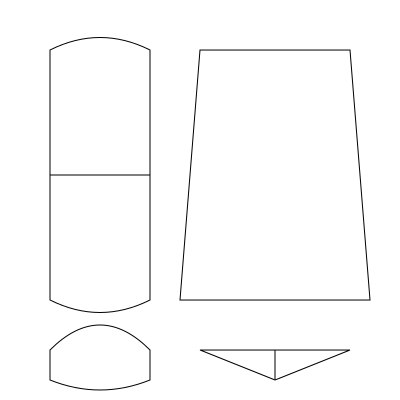As a culture writer, identify the musical instrument that originates from Aboriginal Australian culture and is known for its distinctive drone sound. To answer this question, let's analyze each instrument depicted in the image:

1. Top-left: This is a sitar, a stringed instrument from India. It has a long neck and a large, pear-shaped resonating chamber.

2. Top-right: This is a didgeridoo, a wind instrument developed by Indigenous Australians. It's a long, hollow wooden tube that produces a deep, resonant drone sound.

3. Bottom-left: This is a djembe, a goblet-shaped drum originating from West Africa.

4. Bottom-right: This is a balalaika, a triangular-bodied string instrument from Russia.

Among these instruments, only the didgeridoo originates from Aboriginal Australian culture. It is well-known for its distinctive drone sound, which is produced by continuous circular breathing technique. This instrument has great cultural significance and is often used in ceremonial contexts as well as contemporary music.

As a culture writer seeking to spread awareness about important cultural contributions, recognizing the didgeridoo is crucial for understanding and appreciating Aboriginal Australian musical heritage.
Answer: Didgeridoo 